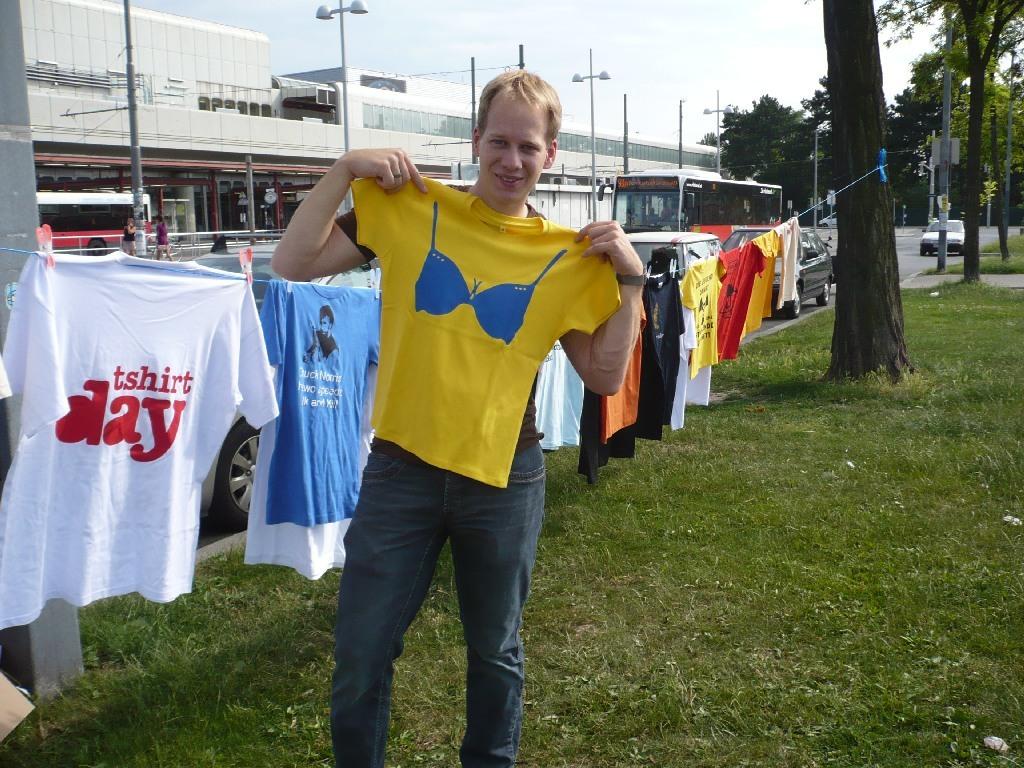What day does it say on the white t-shirt?
Ensure brevity in your answer.  Tshirt day. What is pictured on the yellow shirt?
Provide a succinct answer. Answering does not require reading text in the image. 